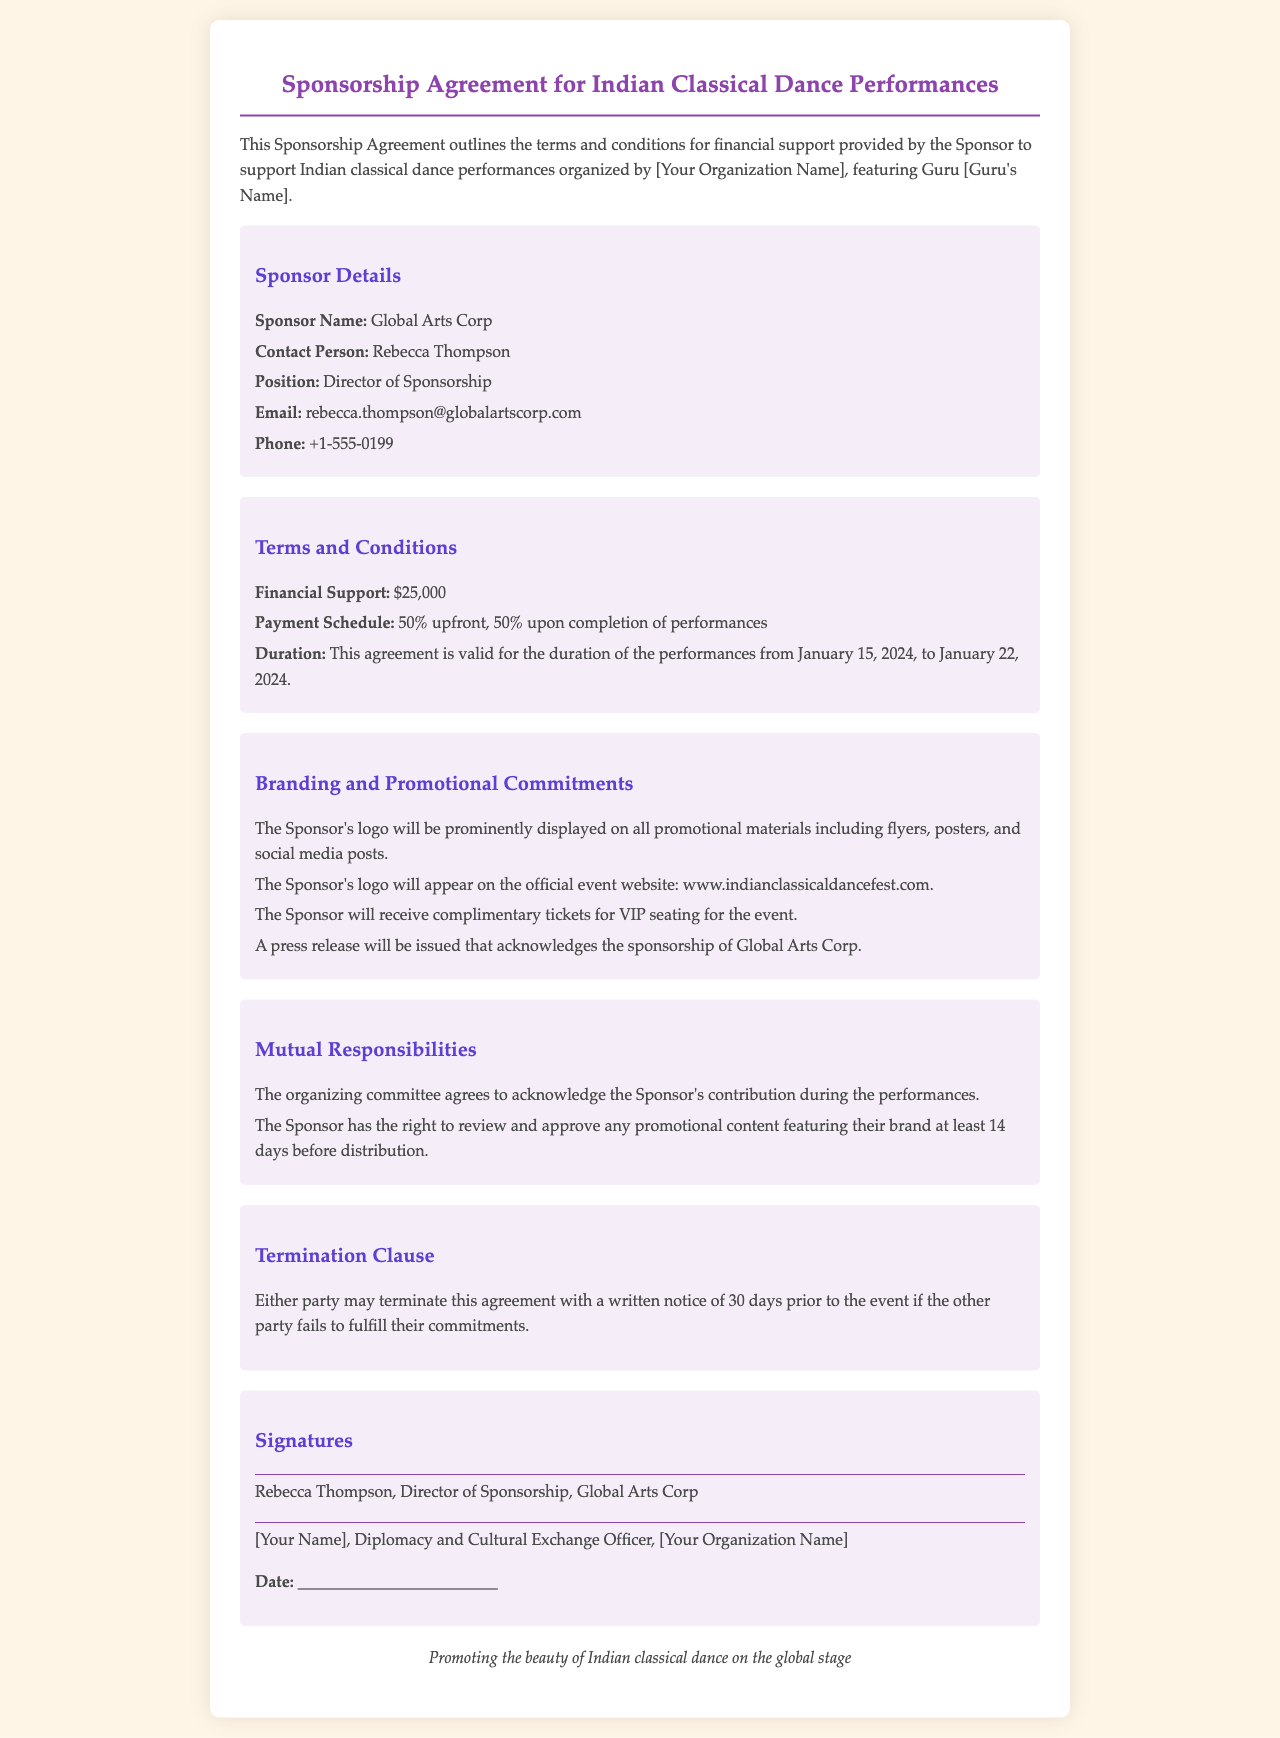What is the total financial support amount provided by the Sponsor? The total financial support amount is stated directly in the document as $25,000.
Answer: $25,000 What percentage of the payment is required upfront? The document specifies the payment schedule, which states that 50% is required upfront.
Answer: 50% On what date does the agreement start? The duration of the performances mentioned in the document begins on January 15, 2024.
Answer: January 15, 2024 What kind of promotional materials will feature the Sponsor's logo? The document states that the Sponsor's logo will be displayed on promotional materials including flyers, posters, and social media posts.
Answer: flyers, posters, and social media posts What is the notice period for termination mentioned in the agreement? The termination clause specifies that a written notice of 30 days is required prior to the event for termination.
Answer: 30 days What is the title of the contact person for the Sponsor? The document mentions the contact person's title as Director of Sponsorship.
Answer: Director of Sponsorship How many complimentary tickets will the Sponsor receive? The document confirms that the Sponsor will receive complimentary tickets for VIP seating for the event, though it does not specify a number.
Answer: VIP seating (not specified) Who is responsible for acknowledging the Sponsor's contribution during the performances? The mutual responsibilities section states that the organizing committee agrees to acknowledge the Sponsor's contribution.
Answer: Organizing committee 